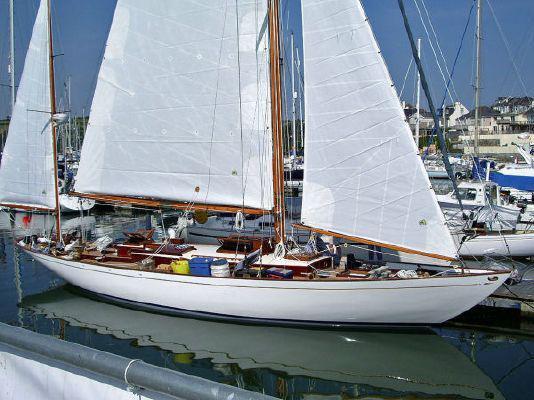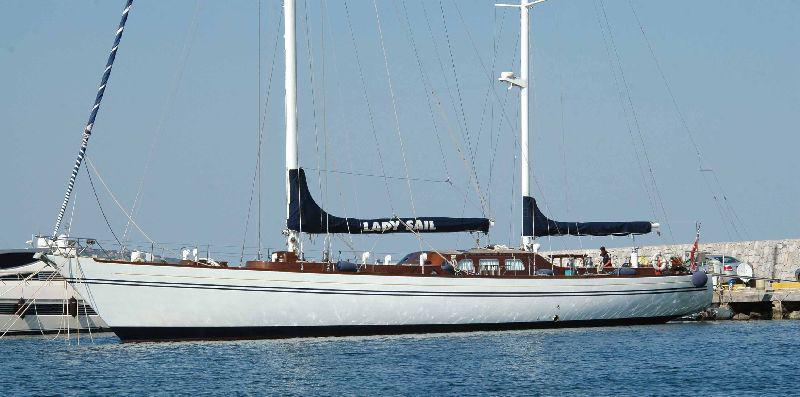The first image is the image on the left, the second image is the image on the right. Examine the images to the left and right. Is the description "One sailboat has its sails furled and the other has sails unfurled." accurate? Answer yes or no. Yes. The first image is the image on the left, the second image is the image on the right. Considering the images on both sides, is "One of the sailboats is blue." valid? Answer yes or no. No. 